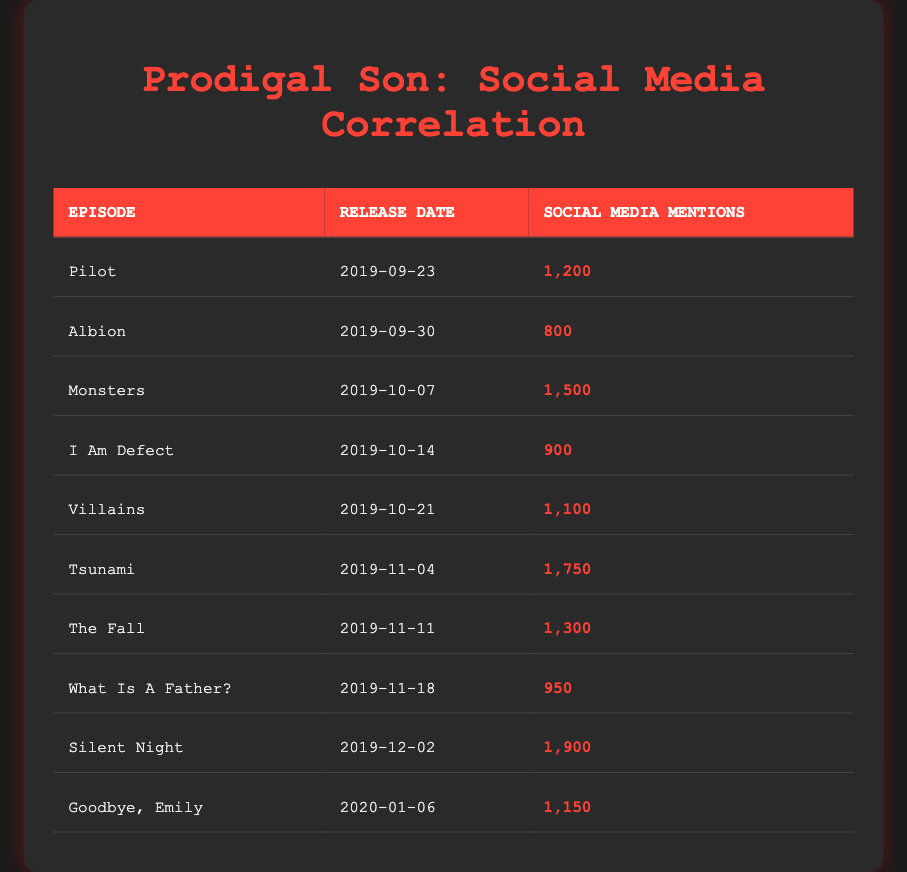What episode had the highest social media mentions? By examining the "Social Media Mentions" column, the row for "Silent Night" shows the highest count of 1900.
Answer: Silent Night Which episode had more mentions, "Tsunami" or "The Fall"? "Tsunami" had 1750 mentions while "The Fall" had 1300 mentions, so Tsunami had more mentions.
Answer: Tsunami What is the average number of social media mentions across all episodes? Adding all the mentions (1200 + 800 + 1500 + 900 + 1100 + 1750 + 1300 + 950 + 1900 + 1150 = 10350) and dividing by the number of episodes (10) gives an average of 1035.
Answer: 1035 Did "Albion" have more mentions than "Villains"? "Albion" had 800 mentions and "Villains" had 1100 mentions. Since 800 is less than 1100, Albion did not have more mentions.
Answer: No What is the total number of social media mentions for episodes released in November? The episodes "Tsunami" (1750), "The Fall" (1300), and "What Is A Father?" (950) were released in November. Adding those mentions gives (1750 + 1300 + 950 = 4000).
Answer: 4000 Was the release of the "Pilot" episode the earliest compared to all other episodes? The "Pilot" episode was released on September 23, 2019, which is indeed earlier than any of the other episodes listed, confirming it's the earliest.
Answer: Yes Which episode was released immediately after "Monsters"? The episode that follows "Monsters" (released on October 7) is "I Am Defect," which was released on October 14, 2019.
Answer: I Am Defect What is the difference in social media mentions between the episodes "Silent Night" and "Goodbye, Emily"? "Silent Night" had 1900 mentions while "Goodbye, Emily" had 1150. The difference is 1900 - 1150 = 750.
Answer: 750 Which two episodes had similar mentions, differing by less than 200? The episodes "Goodbye, Emily" (1150) and "Villains" (1100) both had mentions that differ by only 50, which is less than 200.
Answer: Goodbye, Emily and Villains 